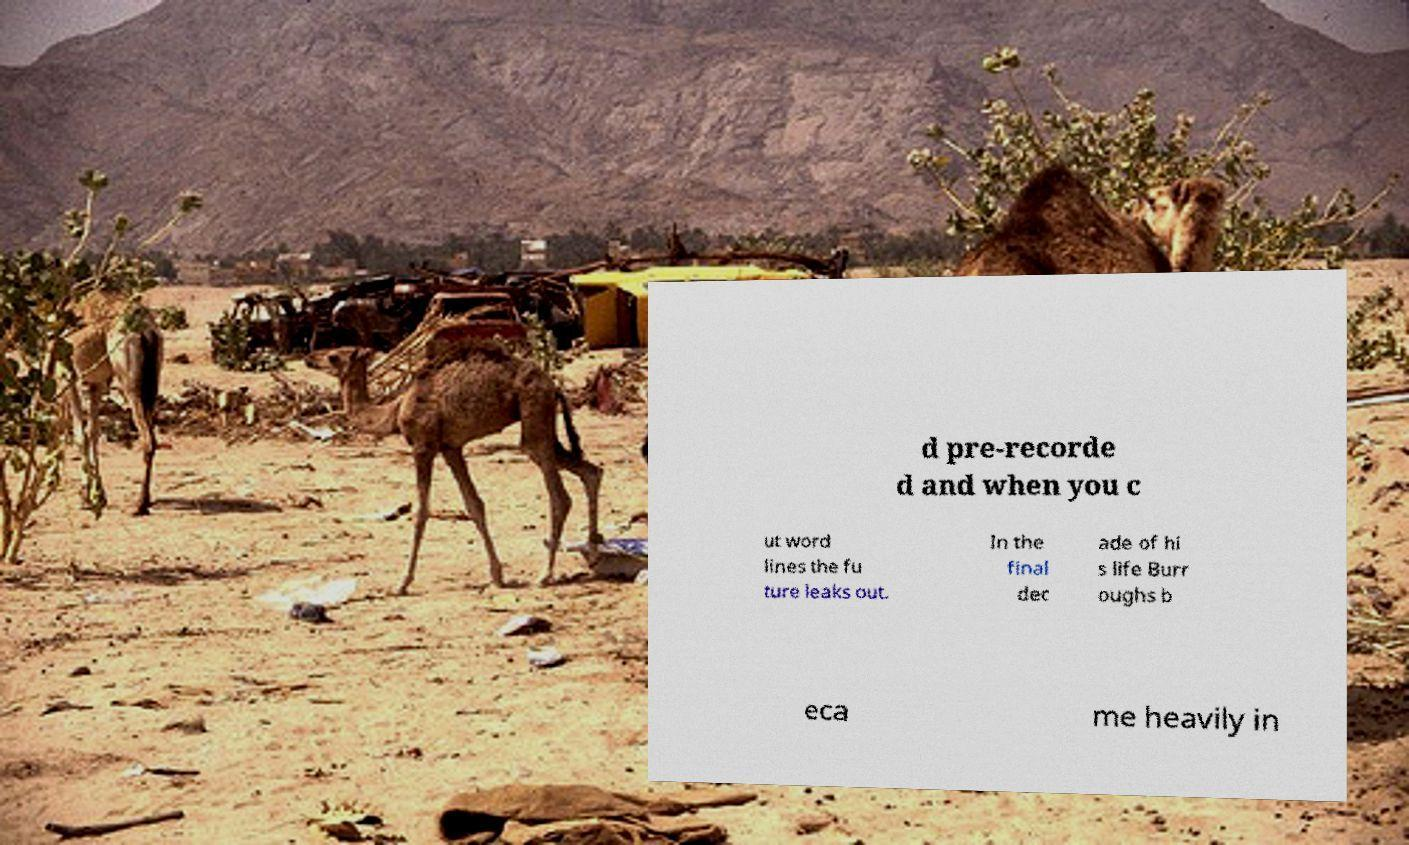For documentation purposes, I need the text within this image transcribed. Could you provide that? d pre-recorde d and when you c ut word lines the fu ture leaks out. In the final dec ade of hi s life Burr oughs b eca me heavily in 